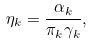<formula> <loc_0><loc_0><loc_500><loc_500>\eta _ { k } = \frac { \alpha _ { k } } { \pi _ { k } \gamma _ { k } } ,</formula> 